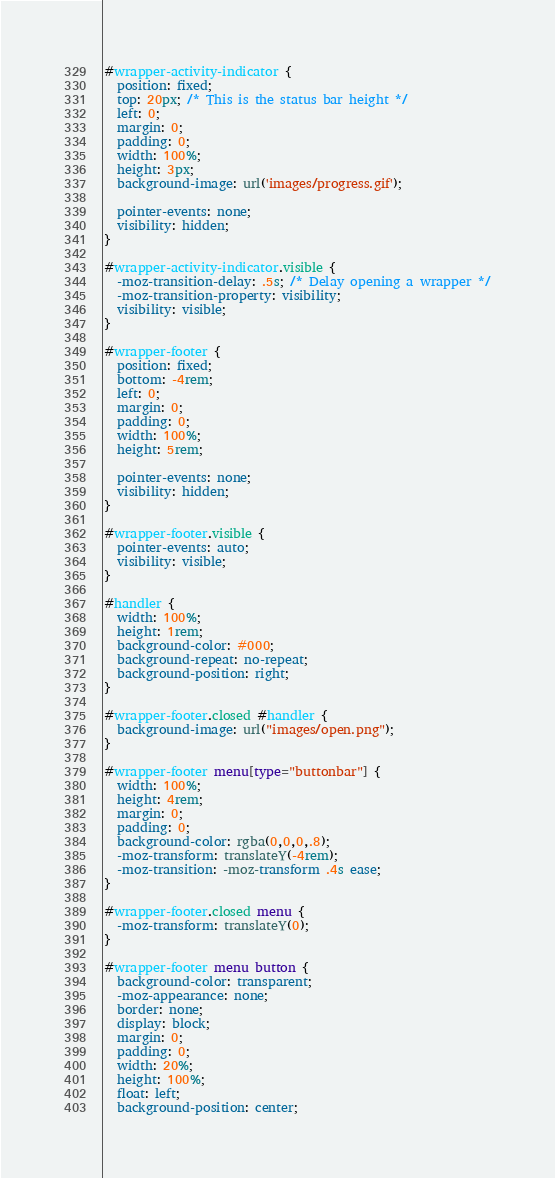Convert code to text. <code><loc_0><loc_0><loc_500><loc_500><_CSS_>
#wrapper-activity-indicator {
  position: fixed;
  top: 20px; /* This is the status bar height */
  left: 0;
  margin: 0;
  padding: 0;
  width: 100%;
  height: 3px;
  background-image: url('images/progress.gif');

  pointer-events: none;
  visibility: hidden;
}

#wrapper-activity-indicator.visible {
  -moz-transition-delay: .5s; /* Delay opening a wrapper */
  -moz-transition-property: visibility;
  visibility: visible;
}

#wrapper-footer {
  position: fixed;
  bottom: -4rem;
  left: 0;
  margin: 0;
  padding: 0;
  width: 100%;
  height: 5rem;

  pointer-events: none;
  visibility: hidden;
}

#wrapper-footer.visible {
  pointer-events: auto;
  visibility: visible;
}

#handler {
  width: 100%;
  height: 1rem;
  background-color: #000;
  background-repeat: no-repeat;
  background-position: right;
}

#wrapper-footer.closed #handler {
  background-image: url("images/open.png");
}

#wrapper-footer menu[type="buttonbar"] {
  width: 100%;
  height: 4rem;
  margin: 0;
  padding: 0;
  background-color: rgba(0,0,0,.8);
  -moz-transform: translateY(-4rem);
  -moz-transition: -moz-transform .4s ease;
}

#wrapper-footer.closed menu {
  -moz-transform: translateY(0);
}

#wrapper-footer menu button {
  background-color: transparent;
  -moz-appearance: none;
  border: none;
  display: block;
  margin: 0;
  padding: 0;
  width: 20%;
  height: 100%;
  float: left;
  background-position: center;</code> 